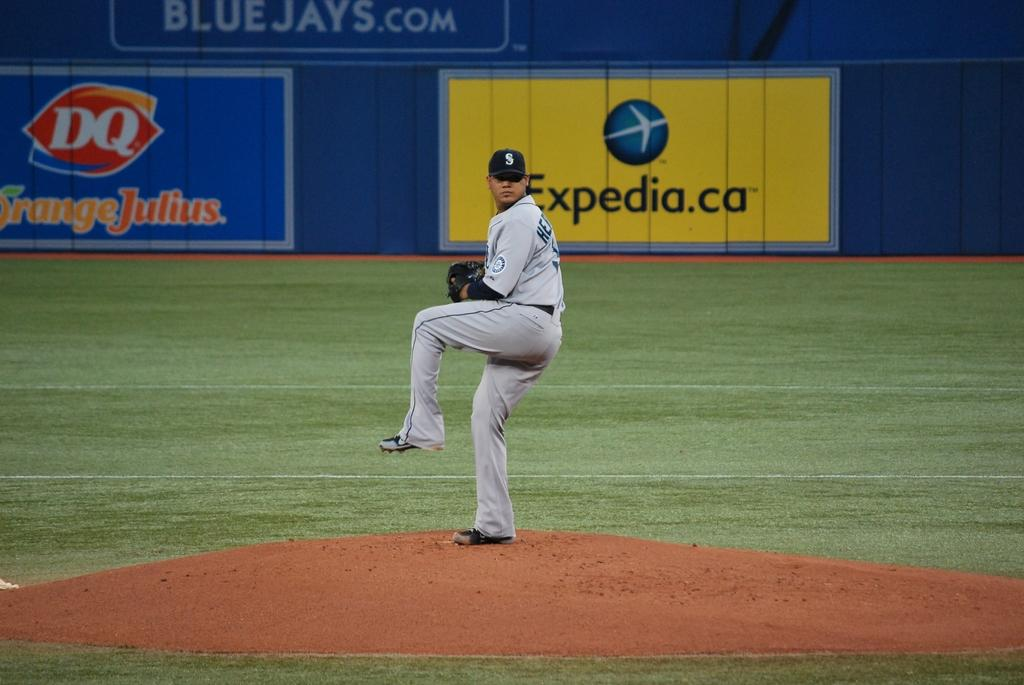<image>
Write a terse but informative summary of the picture. A baseball player is about to throw a pitch with an expedia ad in the background. 